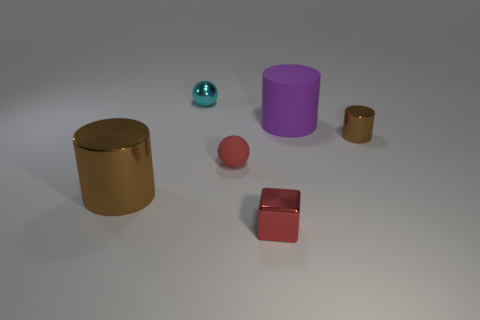If you had to guess, what material do you think these objects are made of? Based on the visual characteristics, it seems the gold and brown cylinders exhibit a reflective surface similar to that of metal. The purple cylinder, in contrast, has a satin-like finish which suggests it could be made of a different material, possibly plastic or painted metal. The cube's matte finish resembles ceramic or rubber, whereas the small teal sphere has a glossy appearance that might be indicative of glass or polished stone. 